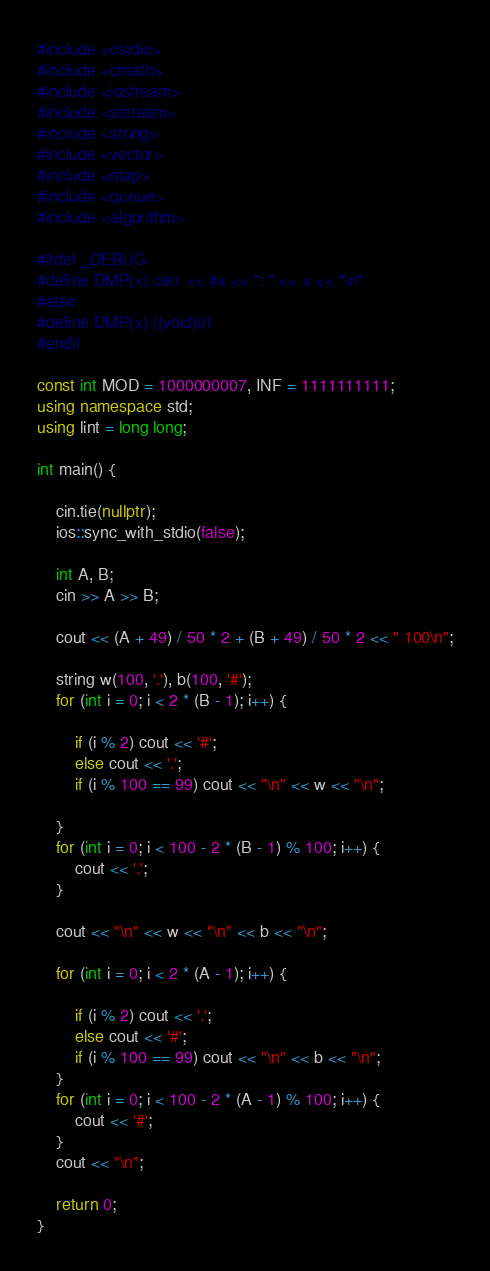<code> <loc_0><loc_0><loc_500><loc_500><_C++_>#include <cstdio>
#include <cmath>
#include <iostream>
#include <sstream>
#include <string>
#include <vector>
#include <map>
#include <queue>
#include <algorithm>

#ifdef _DEBUG
#define DMP(x) cerr << #x << ": " << x << "\n"
#else
#define DMP(x) ((void)0)
#endif

const int MOD = 1000000007, INF = 1111111111; 
using namespace std;
using lint = long long;

int main() {

	cin.tie(nullptr);
	ios::sync_with_stdio(false);

	int A, B;
	cin >> A >> B;

	cout << (A + 49) / 50 * 2 + (B + 49) / 50 * 2 << " 100\n";

	string w(100, '.'), b(100, '#');
	for (int i = 0; i < 2 * (B - 1); i++) {
		
		if (i % 2) cout << '#';
		else cout << '.';
		if (i % 100 == 99) cout << "\n" << w << "\n";

	}
	for (int i = 0; i < 100 - 2 * (B - 1) % 100; i++) {
		cout << '.';
	}

	cout << "\n" << w << "\n" << b << "\n";

	for (int i = 0; i < 2 * (A - 1); i++) {

		if (i % 2) cout << '.';
		else cout << '#';
		if (i % 100 == 99) cout << "\n" << b << "\n";
	}
	for (int i = 0; i < 100 - 2 * (A - 1) % 100; i++) {
		cout << '#';
	}
	cout << "\n";

	return 0;
}</code> 